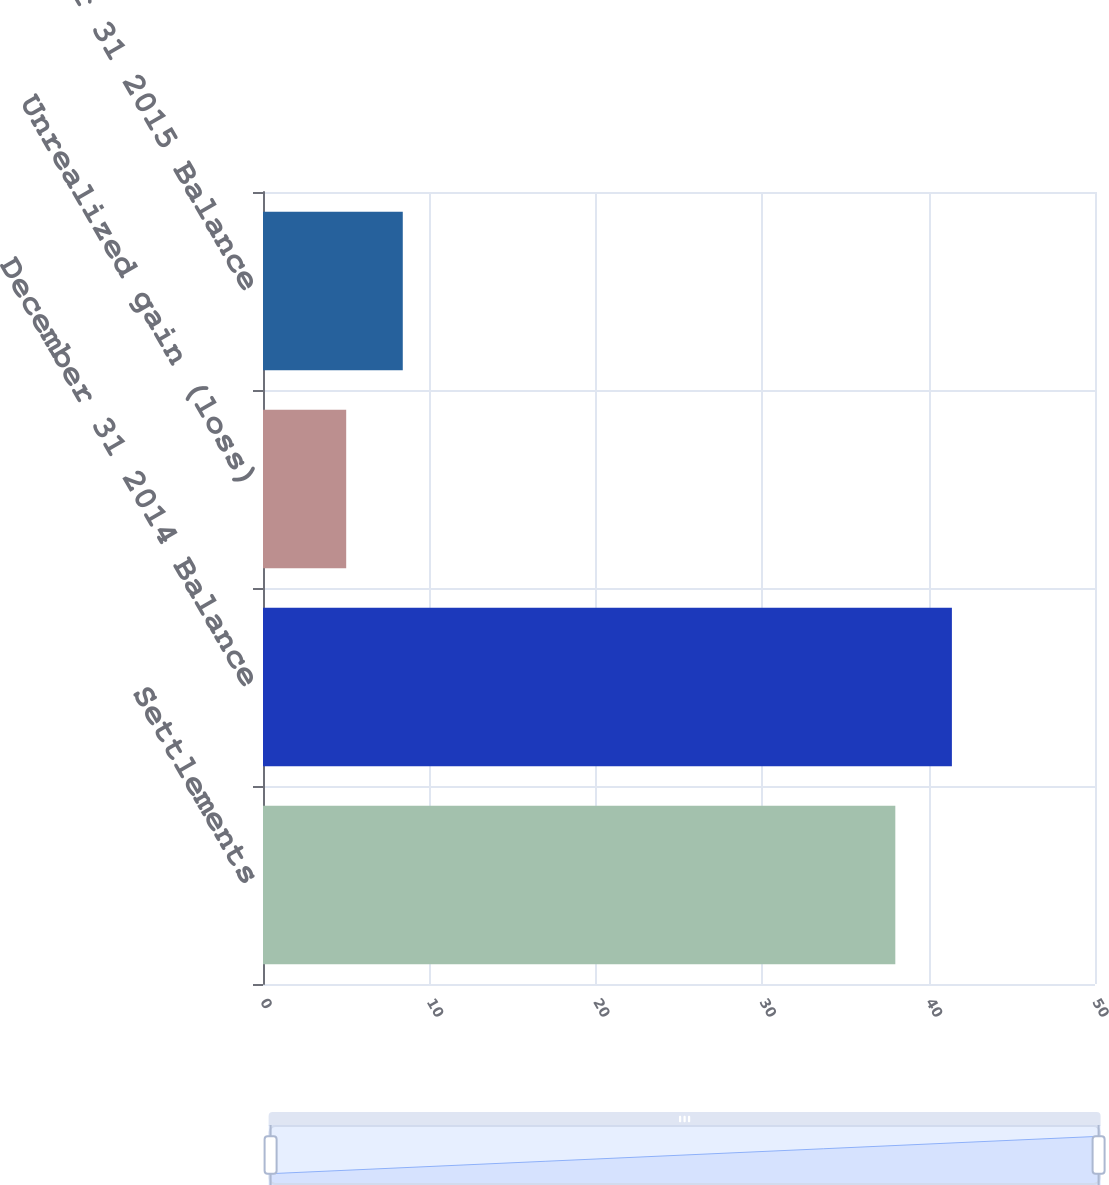<chart> <loc_0><loc_0><loc_500><loc_500><bar_chart><fcel>Settlements<fcel>December 31 2014 Balance<fcel>Unrealized gain (loss)<fcel>December 31 2015 Balance<nl><fcel>38<fcel>41.4<fcel>5<fcel>8.4<nl></chart> 